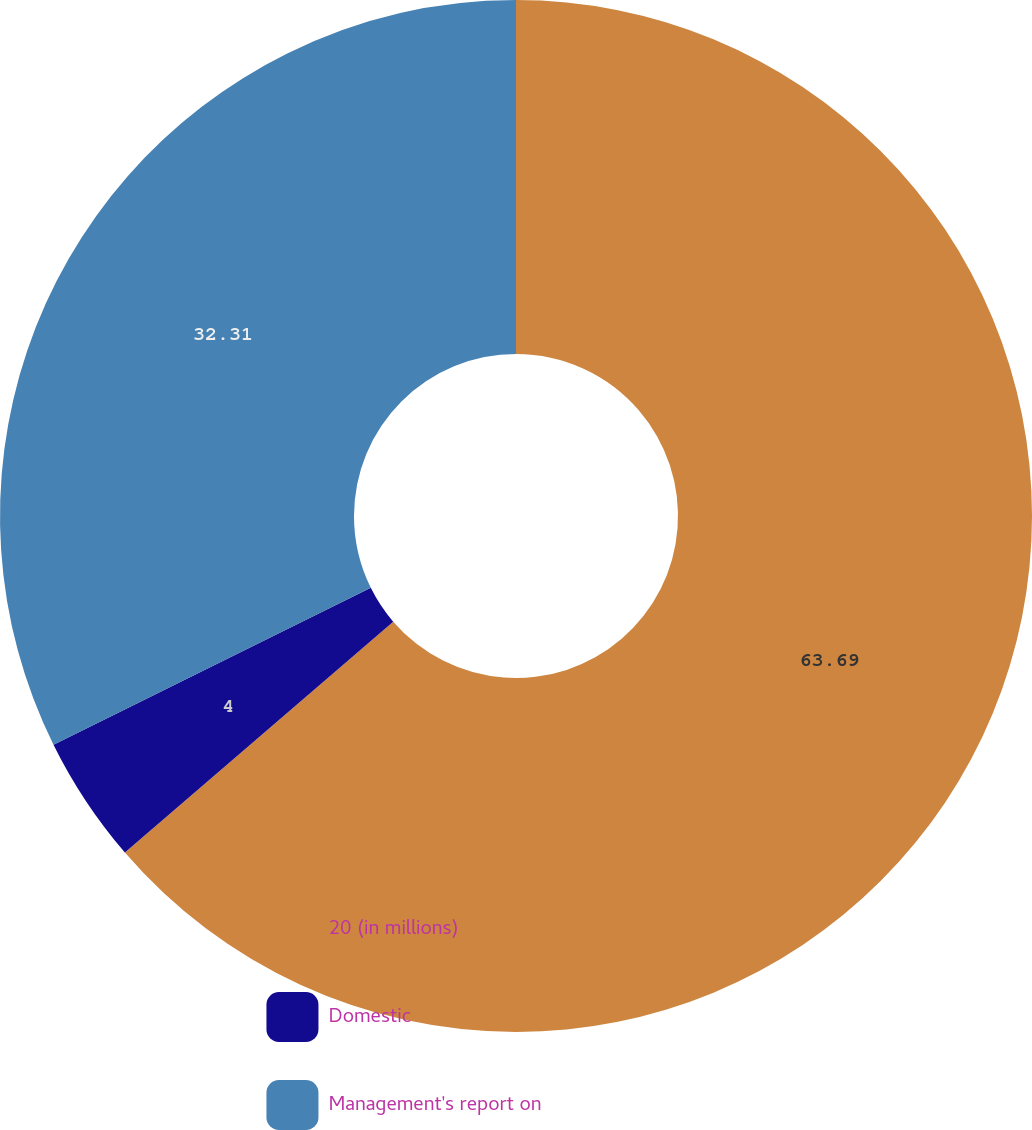Convert chart to OTSL. <chart><loc_0><loc_0><loc_500><loc_500><pie_chart><fcel>20 (in millions)<fcel>Domestic<fcel>Management's report on<nl><fcel>63.69%<fcel>4.0%<fcel>32.31%<nl></chart> 